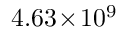<formula> <loc_0><loc_0><loc_500><loc_500>4 . 6 3 \, \times \, 1 0 ^ { 9 }</formula> 